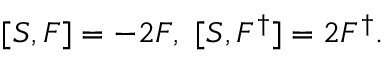Convert formula to latex. <formula><loc_0><loc_0><loc_500><loc_500>[ S , F ] = - 2 F , [ S , F ^ { \dagger } ] = 2 F ^ { \dagger } .</formula> 